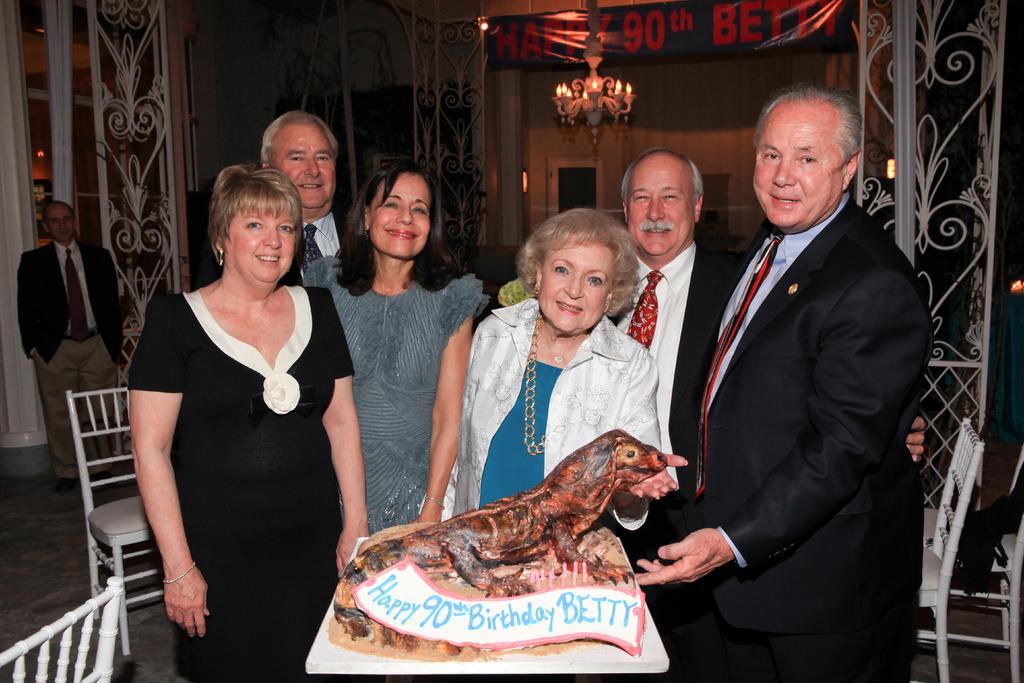Describe this image in one or two sentences. There is a group of person standing in the middle of this image. There are some chairs on the left side of this image and right side of this image as well. There is a wall in the background. There is one person's standing on the left side of this image. There is a cake at the bottom of this image. 